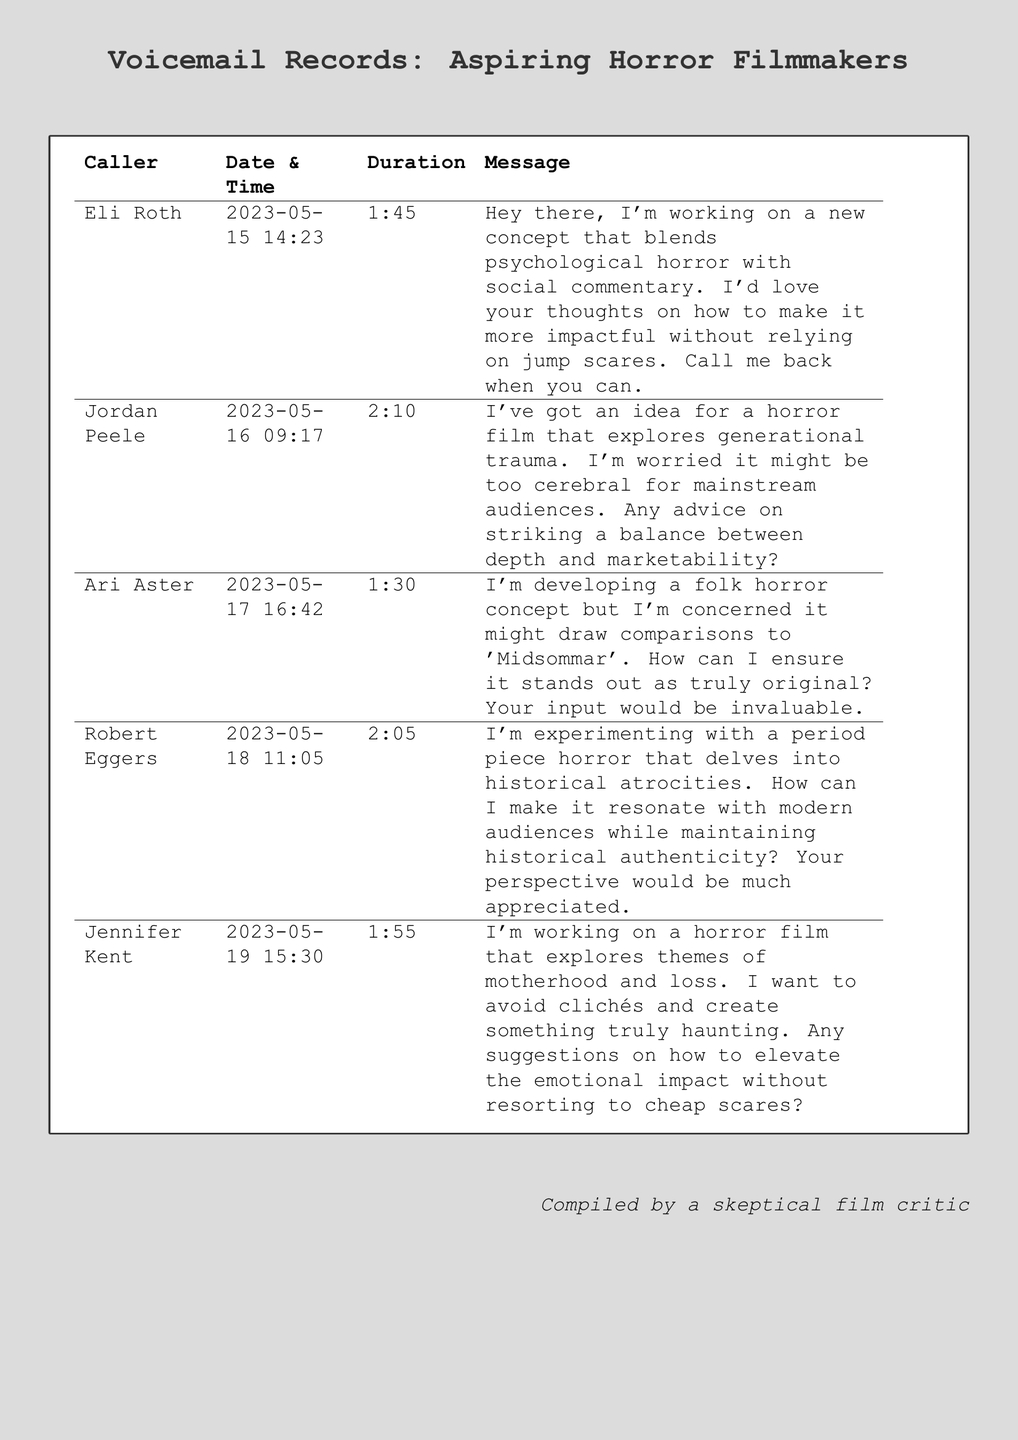What is the first caller's name? The first caller in the voicemail records is Eli Roth.
Answer: Eli Roth What date did Jordan Peele leave a message? The date Jordan Peele left a message is recorded as 2023-05-16.
Answer: 2023-05-16 What is the duration of Robert Eggers' message? The document shows Robert Eggers' message duration is 2:05.
Answer: 2:05 What theme is Jennifer Kent's horror film exploring? Jennifer Kent is exploring themes of motherhood and loss in her horror film.
Answer: motherhood and loss Which filmmaker is concerned about comparisons to 'Midsommar'? Ari Aster expressed concerns about comparisons to 'Midsommar'.
Answer: Ari Aster How many voicemails were left in total? The document lists a total of five voicemail messages from aspiring filmmakers.
Answer: five What is the main focus of Eli Roth's concept? Eli Roth’s concept focuses on psychological horror with social commentary.
Answer: psychological horror with social commentary What advice is Jordan Peele seeking? Jordan Peele is seeking advice on balancing depth and marketability for his film.
Answer: balancing depth and marketability Which filmmaker mentions experimenting with a period piece horror? Robert Eggers mentions experimenting with a period piece horror.
Answer: Robert Eggers 